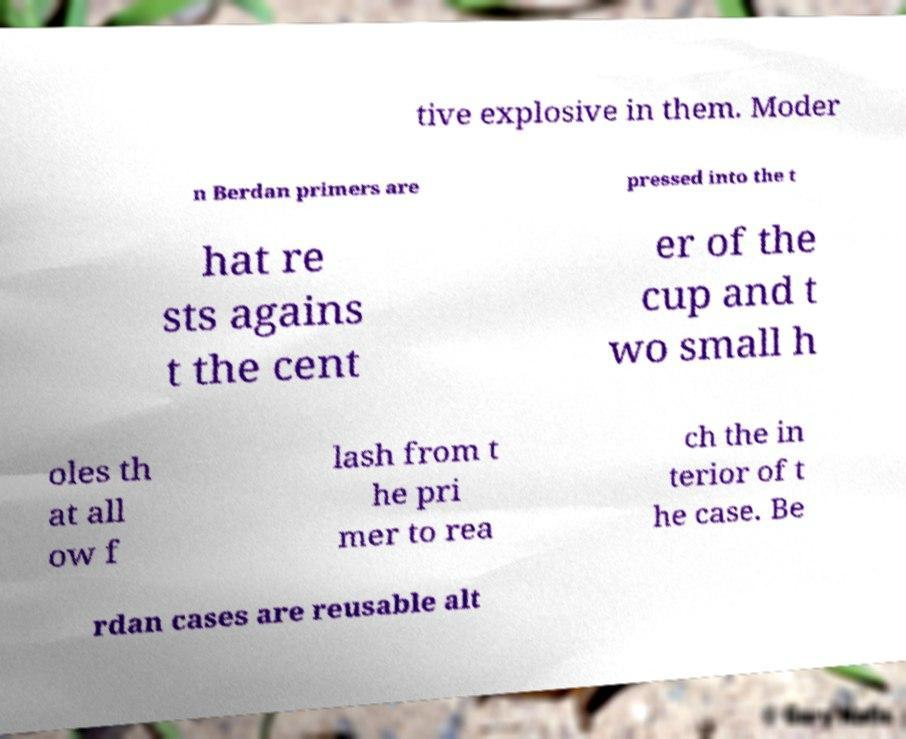For documentation purposes, I need the text within this image transcribed. Could you provide that? tive explosive in them. Moder n Berdan primers are pressed into the t hat re sts agains t the cent er of the cup and t wo small h oles th at all ow f lash from t he pri mer to rea ch the in terior of t he case. Be rdan cases are reusable alt 